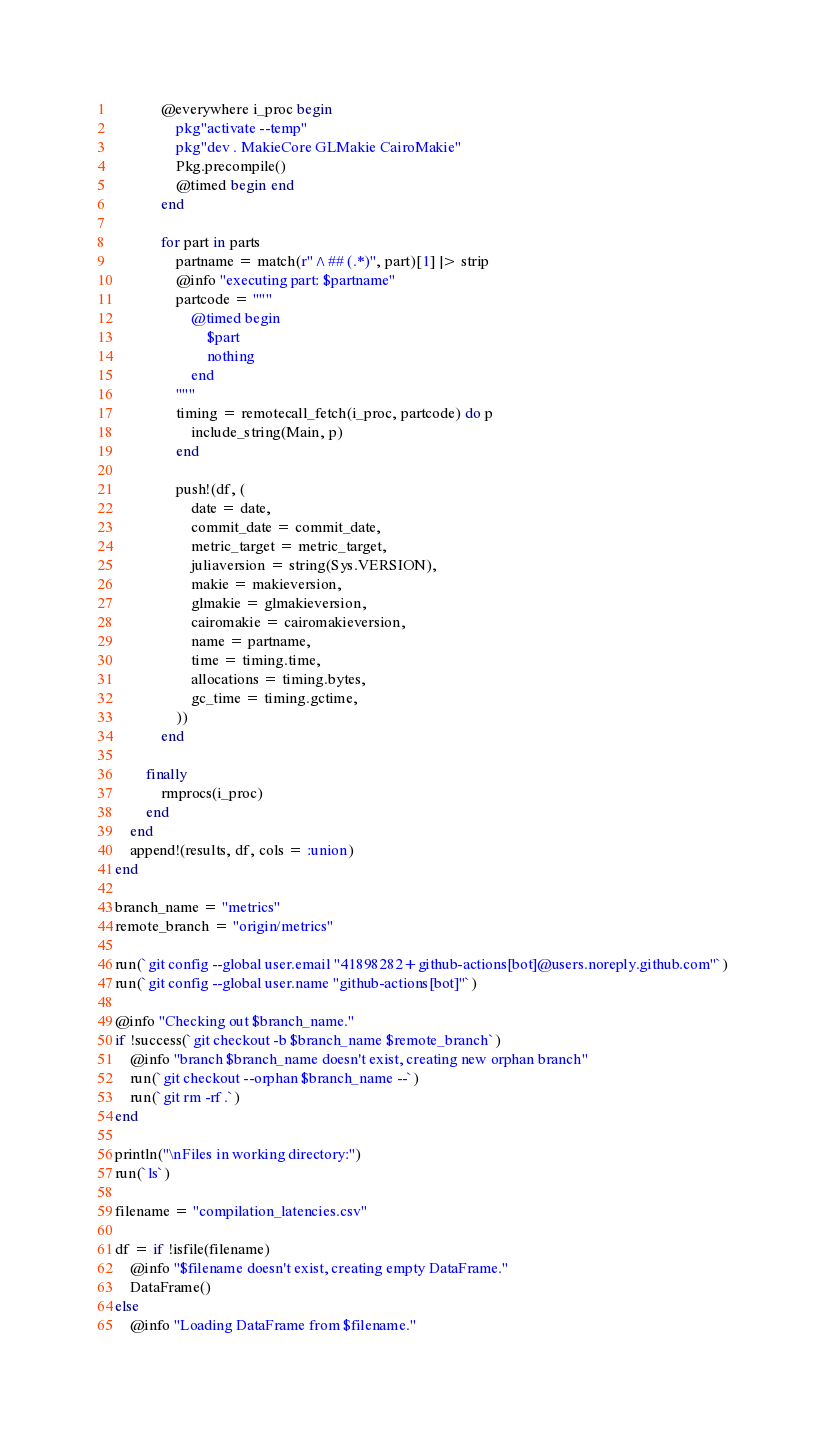Convert code to text. <code><loc_0><loc_0><loc_500><loc_500><_Julia_>            @everywhere i_proc begin
                pkg"activate --temp"
                pkg"dev . MakieCore GLMakie CairoMakie"
                Pkg.precompile()
                @timed begin end
            end

            for part in parts
                partname = match(r"^## (.*)", part)[1] |> strip
                @info "executing part: $partname"
                partcode = """
                    @timed begin
                        $part
                        nothing
                    end
                """
                timing = remotecall_fetch(i_proc, partcode) do p
                    include_string(Main, p)
                end

                push!(df, (
                    date = date,
                    commit_date = commit_date,
                    metric_target = metric_target,
                    juliaversion = string(Sys.VERSION),
                    makie = makieversion,
                    glmakie = glmakieversion,
                    cairomakie = cairomakieversion,
                    name = partname,
                    time = timing.time,
                    allocations = timing.bytes,
                    gc_time = timing.gctime,
                ))
            end

        finally
            rmprocs(i_proc)
        end    
    end
    append!(results, df, cols = :union)
end

branch_name = "metrics"
remote_branch = "origin/metrics"

run(`git config --global user.email "41898282+github-actions[bot]@users.noreply.github.com"`)
run(`git config --global user.name "github-actions[bot]"`)

@info "Checking out $branch_name."
if !success(`git checkout -b $branch_name $remote_branch`)
    @info "branch $branch_name doesn't exist, creating new orphan branch"
    run(`git checkout --orphan $branch_name --`)
    run(`git rm -rf .`)
end

println("\nFiles in working directory:")
run(`ls`)

filename = "compilation_latencies.csv"

df = if !isfile(filename)
    @info "$filename doesn't exist, creating empty DataFrame."
    DataFrame()
else
    @info "Loading DataFrame from $filename."</code> 